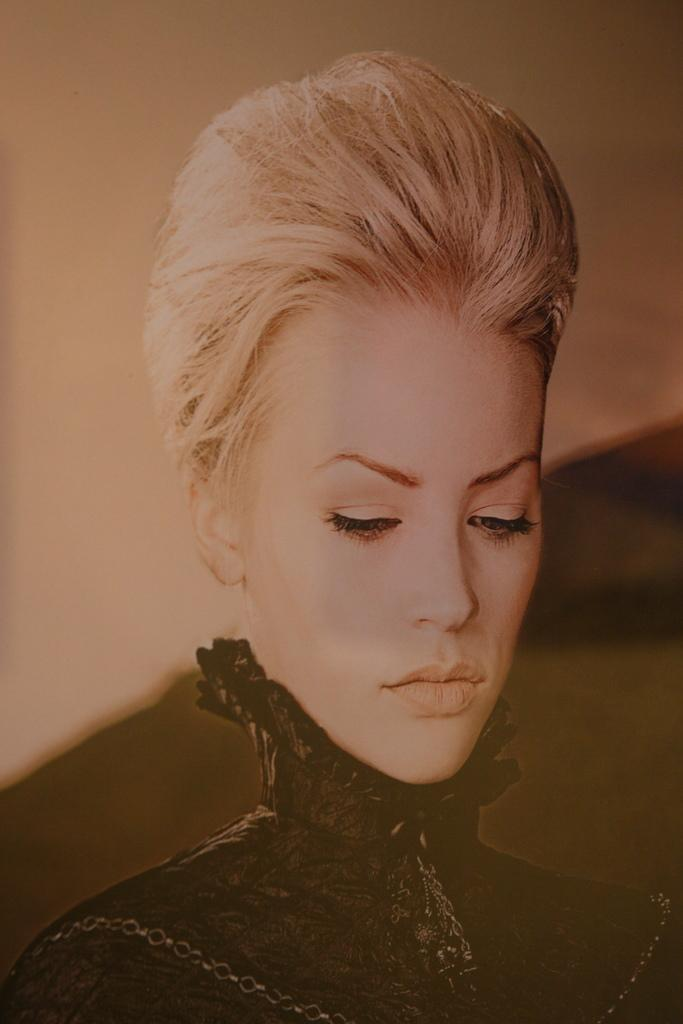What is present in the image? There is a person in the image. Can you describe the person? The person is a woman. What is the woman wearing? The woman is wearing a black dress. How many books can be seen on the woman's feet in the image? There are no books or feet visible in the image; it only shows a woman wearing a black dress. 